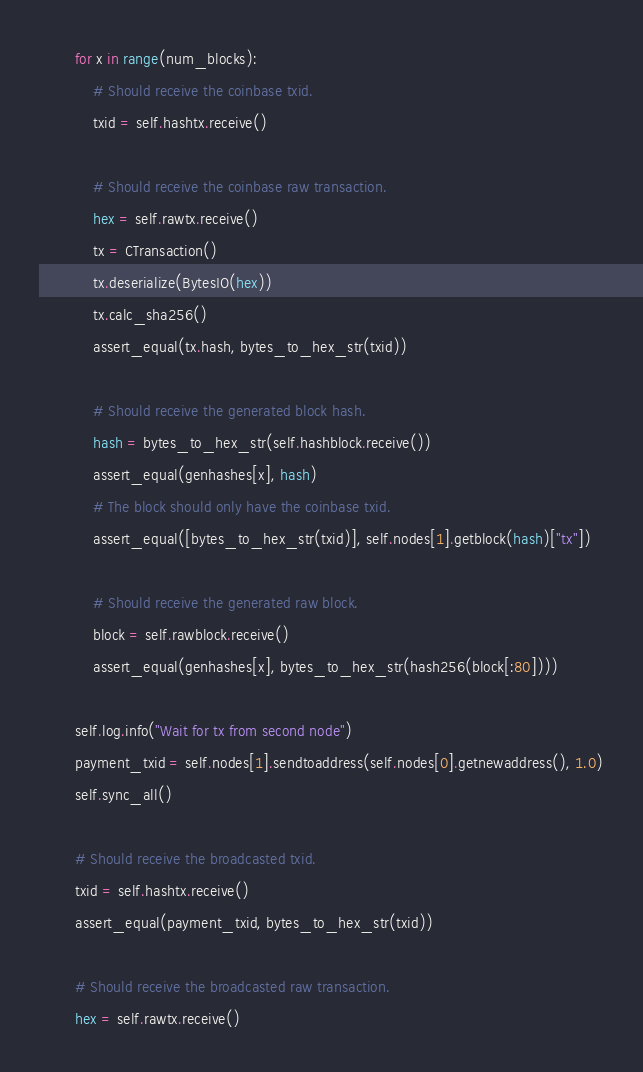<code> <loc_0><loc_0><loc_500><loc_500><_Python_>
        for x in range(num_blocks):
            # Should receive the coinbase txid.
            txid = self.hashtx.receive()

            # Should receive the coinbase raw transaction.
            hex = self.rawtx.receive()
            tx = CTransaction()
            tx.deserialize(BytesIO(hex))
            tx.calc_sha256()
            assert_equal(tx.hash, bytes_to_hex_str(txid))

            # Should receive the generated block hash.
            hash = bytes_to_hex_str(self.hashblock.receive())
            assert_equal(genhashes[x], hash)
            # The block should only have the coinbase txid.
            assert_equal([bytes_to_hex_str(txid)], self.nodes[1].getblock(hash)["tx"])

            # Should receive the generated raw block.
            block = self.rawblock.receive()
            assert_equal(genhashes[x], bytes_to_hex_str(hash256(block[:80])))

        self.log.info("Wait for tx from second node")
        payment_txid = self.nodes[1].sendtoaddress(self.nodes[0].getnewaddress(), 1.0)
        self.sync_all()

        # Should receive the broadcasted txid.
        txid = self.hashtx.receive()
        assert_equal(payment_txid, bytes_to_hex_str(txid))

        # Should receive the broadcasted raw transaction.
        hex = self.rawtx.receive()</code> 